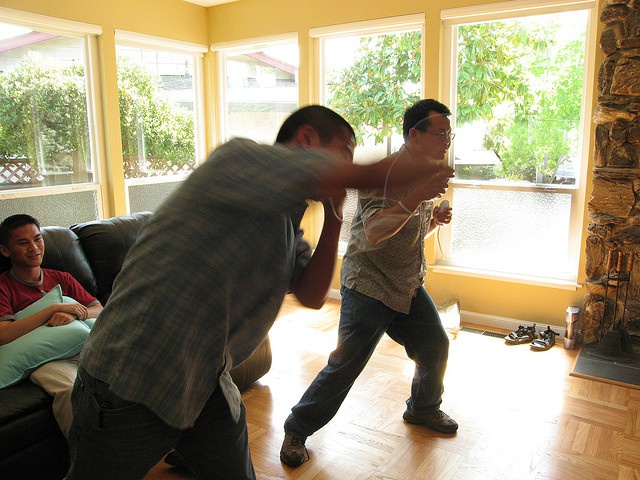Describe the objects in this image and their specific colors. I can see people in tan, black, maroon, and gray tones, people in tan, black, maroon, and ivory tones, couch in tan, black, and gray tones, people in tan, black, maroon, and gray tones, and remote in tan, gray, and brown tones in this image. 